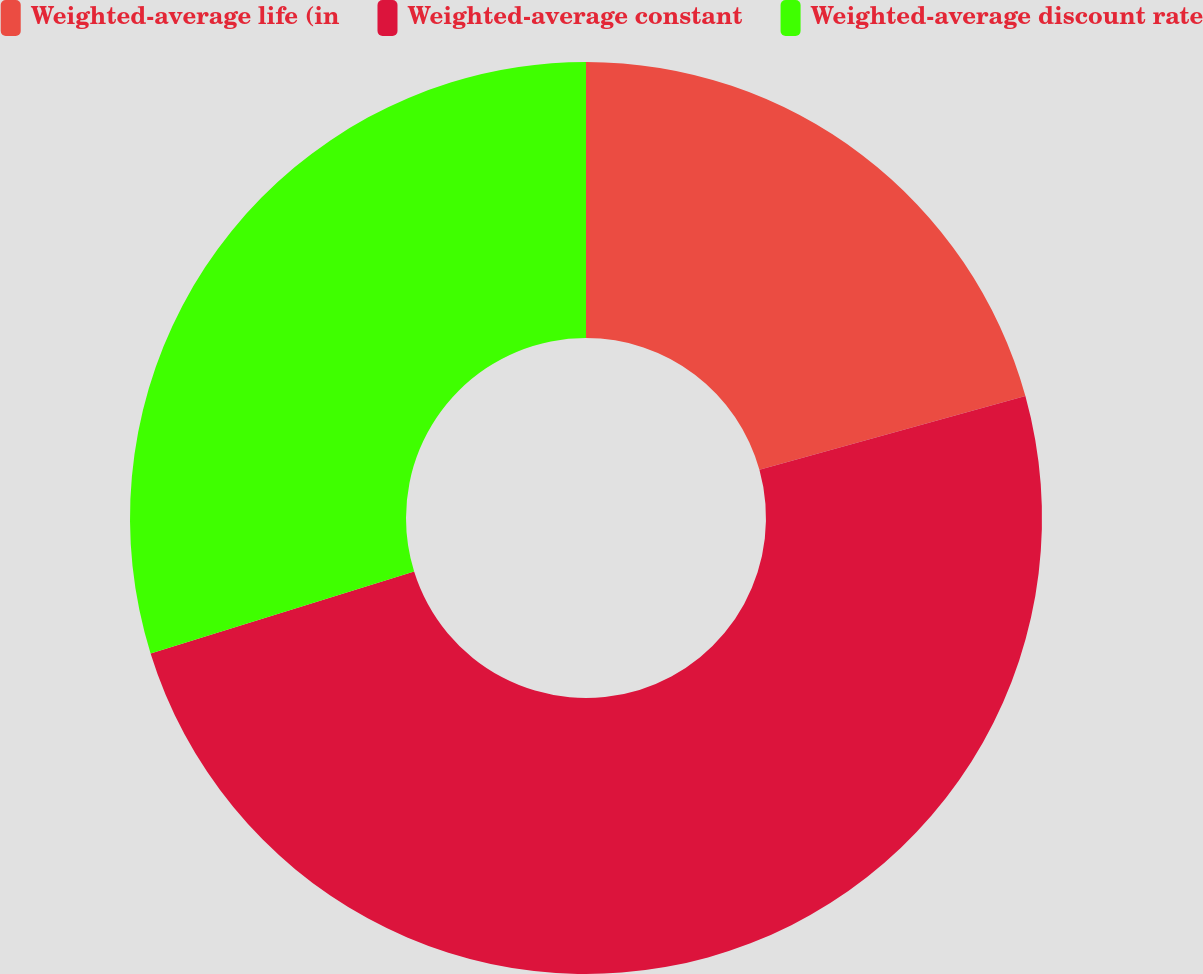Convert chart. <chart><loc_0><loc_0><loc_500><loc_500><pie_chart><fcel>Weighted-average life (in<fcel>Weighted-average constant<fcel>Weighted-average discount rate<nl><fcel>20.69%<fcel>49.51%<fcel>29.8%<nl></chart> 